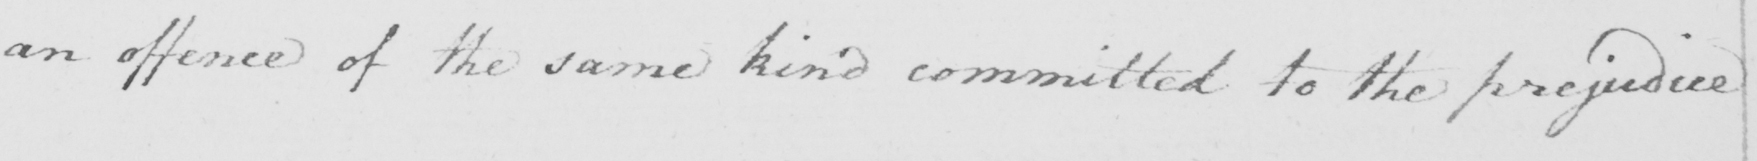What is written in this line of handwriting? an offence of the same kind committed to the prejudice 